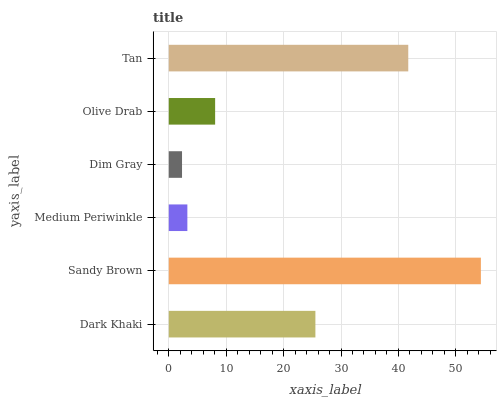Is Dim Gray the minimum?
Answer yes or no. Yes. Is Sandy Brown the maximum?
Answer yes or no. Yes. Is Medium Periwinkle the minimum?
Answer yes or no. No. Is Medium Periwinkle the maximum?
Answer yes or no. No. Is Sandy Brown greater than Medium Periwinkle?
Answer yes or no. Yes. Is Medium Periwinkle less than Sandy Brown?
Answer yes or no. Yes. Is Medium Periwinkle greater than Sandy Brown?
Answer yes or no. No. Is Sandy Brown less than Medium Periwinkle?
Answer yes or no. No. Is Dark Khaki the high median?
Answer yes or no. Yes. Is Olive Drab the low median?
Answer yes or no. Yes. Is Medium Periwinkle the high median?
Answer yes or no. No. Is Tan the low median?
Answer yes or no. No. 